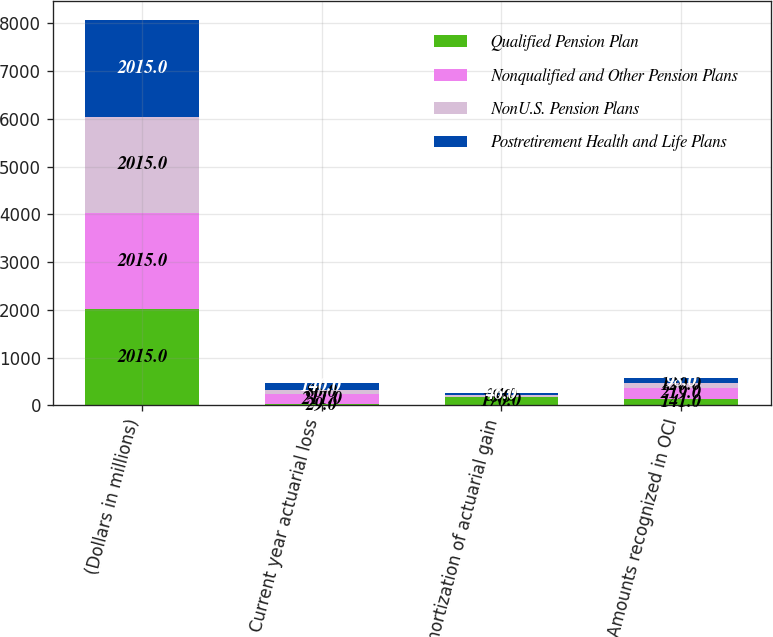<chart> <loc_0><loc_0><loc_500><loc_500><stacked_bar_chart><ecel><fcel>(Dollars in millions)<fcel>Current year actuarial loss<fcel>Amortization of actuarial gain<fcel>Amounts recognized in OCI<nl><fcel>Qualified Pension Plan<fcel>2015<fcel>29<fcel>170<fcel>141<nl><fcel>Nonqualified and Other Pension Plans<fcel>2015<fcel>211<fcel>6<fcel>219<nl><fcel>NonU.S. Pension Plans<fcel>2015<fcel>86<fcel>34<fcel>120<nl><fcel>Postretirement Health and Life Plans<fcel>2015<fcel>140<fcel>46<fcel>98<nl></chart> 